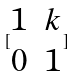Convert formula to latex. <formula><loc_0><loc_0><loc_500><loc_500>[ \begin{matrix} 1 & k \\ 0 & 1 \end{matrix} ]</formula> 